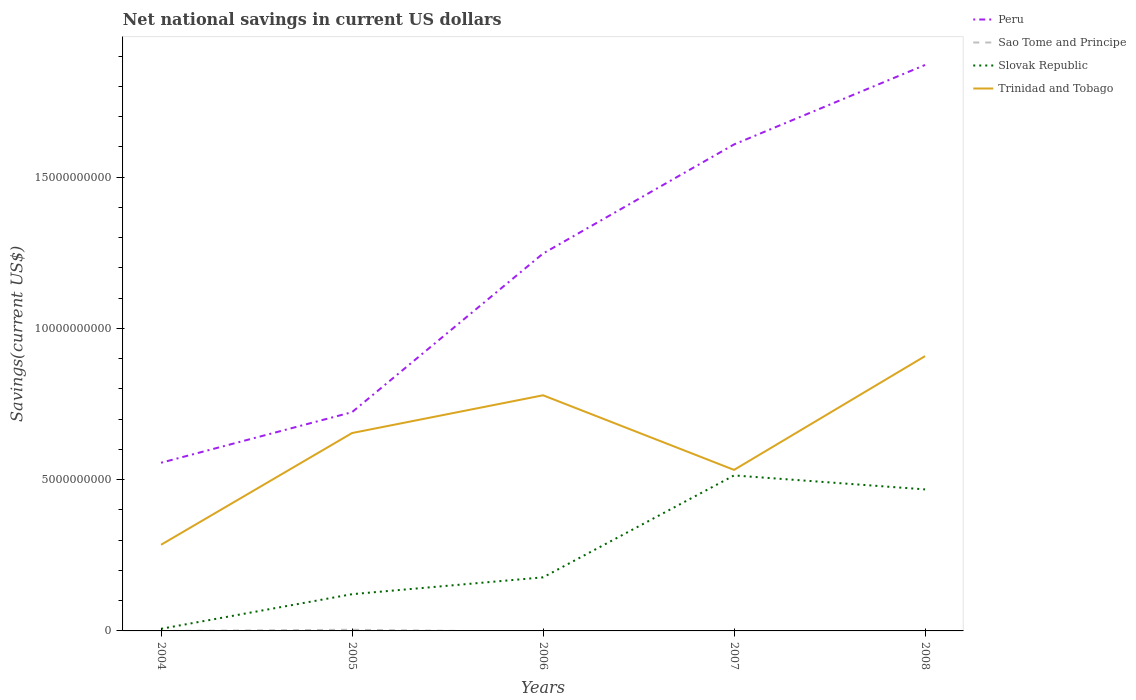How many different coloured lines are there?
Provide a short and direct response. 4. Is the number of lines equal to the number of legend labels?
Offer a terse response. No. Across all years, what is the maximum net national savings in Trinidad and Tobago?
Your answer should be compact. 2.85e+09. What is the total net national savings in Peru in the graph?
Provide a succinct answer. -5.24e+09. What is the difference between the highest and the second highest net national savings in Sao Tome and Principe?
Your response must be concise. 3.84e+07. What is the difference between the highest and the lowest net national savings in Sao Tome and Principe?
Offer a very short reply. 1. Is the net national savings in Trinidad and Tobago strictly greater than the net national savings in Slovak Republic over the years?
Give a very brief answer. No. Does the graph contain grids?
Make the answer very short. No. Where does the legend appear in the graph?
Provide a short and direct response. Top right. How are the legend labels stacked?
Make the answer very short. Vertical. What is the title of the graph?
Offer a very short reply. Net national savings in current US dollars. Does "Jordan" appear as one of the legend labels in the graph?
Your response must be concise. No. What is the label or title of the X-axis?
Your answer should be very brief. Years. What is the label or title of the Y-axis?
Provide a succinct answer. Savings(current US$). What is the Savings(current US$) in Peru in 2004?
Offer a very short reply. 5.56e+09. What is the Savings(current US$) in Slovak Republic in 2004?
Provide a short and direct response. 6.97e+07. What is the Savings(current US$) of Trinidad and Tobago in 2004?
Provide a succinct answer. 2.85e+09. What is the Savings(current US$) of Peru in 2005?
Your response must be concise. 7.23e+09. What is the Savings(current US$) of Sao Tome and Principe in 2005?
Keep it short and to the point. 3.84e+07. What is the Savings(current US$) of Slovak Republic in 2005?
Give a very brief answer. 1.21e+09. What is the Savings(current US$) of Trinidad and Tobago in 2005?
Your answer should be compact. 6.54e+09. What is the Savings(current US$) in Peru in 2006?
Your response must be concise. 1.25e+1. What is the Savings(current US$) of Slovak Republic in 2006?
Ensure brevity in your answer.  1.77e+09. What is the Savings(current US$) in Trinidad and Tobago in 2006?
Provide a succinct answer. 7.79e+09. What is the Savings(current US$) of Peru in 2007?
Give a very brief answer. 1.61e+1. What is the Savings(current US$) of Slovak Republic in 2007?
Your answer should be very brief. 5.14e+09. What is the Savings(current US$) of Trinidad and Tobago in 2007?
Make the answer very short. 5.32e+09. What is the Savings(current US$) in Peru in 2008?
Keep it short and to the point. 1.87e+1. What is the Savings(current US$) of Slovak Republic in 2008?
Make the answer very short. 4.68e+09. What is the Savings(current US$) of Trinidad and Tobago in 2008?
Provide a short and direct response. 9.08e+09. Across all years, what is the maximum Savings(current US$) in Peru?
Ensure brevity in your answer.  1.87e+1. Across all years, what is the maximum Savings(current US$) in Sao Tome and Principe?
Your response must be concise. 3.84e+07. Across all years, what is the maximum Savings(current US$) in Slovak Republic?
Give a very brief answer. 5.14e+09. Across all years, what is the maximum Savings(current US$) of Trinidad and Tobago?
Offer a very short reply. 9.08e+09. Across all years, what is the minimum Savings(current US$) in Peru?
Your answer should be very brief. 5.56e+09. Across all years, what is the minimum Savings(current US$) of Slovak Republic?
Provide a succinct answer. 6.97e+07. Across all years, what is the minimum Savings(current US$) in Trinidad and Tobago?
Offer a very short reply. 2.85e+09. What is the total Savings(current US$) in Peru in the graph?
Your answer should be very brief. 6.01e+1. What is the total Savings(current US$) of Sao Tome and Principe in the graph?
Your answer should be compact. 3.84e+07. What is the total Savings(current US$) in Slovak Republic in the graph?
Your answer should be very brief. 1.29e+1. What is the total Savings(current US$) of Trinidad and Tobago in the graph?
Make the answer very short. 3.16e+1. What is the difference between the Savings(current US$) in Peru in 2004 and that in 2005?
Your response must be concise. -1.67e+09. What is the difference between the Savings(current US$) in Slovak Republic in 2004 and that in 2005?
Provide a succinct answer. -1.14e+09. What is the difference between the Savings(current US$) in Trinidad and Tobago in 2004 and that in 2005?
Ensure brevity in your answer.  -3.69e+09. What is the difference between the Savings(current US$) in Peru in 2004 and that in 2006?
Keep it short and to the point. -6.92e+09. What is the difference between the Savings(current US$) of Slovak Republic in 2004 and that in 2006?
Your answer should be compact. -1.70e+09. What is the difference between the Savings(current US$) in Trinidad and Tobago in 2004 and that in 2006?
Your answer should be compact. -4.94e+09. What is the difference between the Savings(current US$) in Peru in 2004 and that in 2007?
Give a very brief answer. -1.05e+1. What is the difference between the Savings(current US$) in Slovak Republic in 2004 and that in 2007?
Offer a terse response. -5.07e+09. What is the difference between the Savings(current US$) in Trinidad and Tobago in 2004 and that in 2007?
Offer a very short reply. -2.48e+09. What is the difference between the Savings(current US$) of Peru in 2004 and that in 2008?
Provide a short and direct response. -1.31e+1. What is the difference between the Savings(current US$) in Slovak Republic in 2004 and that in 2008?
Keep it short and to the point. -4.61e+09. What is the difference between the Savings(current US$) in Trinidad and Tobago in 2004 and that in 2008?
Provide a succinct answer. -6.23e+09. What is the difference between the Savings(current US$) of Peru in 2005 and that in 2006?
Offer a very short reply. -5.24e+09. What is the difference between the Savings(current US$) in Slovak Republic in 2005 and that in 2006?
Provide a succinct answer. -5.56e+08. What is the difference between the Savings(current US$) of Trinidad and Tobago in 2005 and that in 2006?
Provide a succinct answer. -1.25e+09. What is the difference between the Savings(current US$) in Peru in 2005 and that in 2007?
Offer a terse response. -8.85e+09. What is the difference between the Savings(current US$) of Slovak Republic in 2005 and that in 2007?
Your answer should be very brief. -3.92e+09. What is the difference between the Savings(current US$) in Trinidad and Tobago in 2005 and that in 2007?
Your answer should be very brief. 1.22e+09. What is the difference between the Savings(current US$) in Peru in 2005 and that in 2008?
Provide a short and direct response. -1.15e+1. What is the difference between the Savings(current US$) in Slovak Republic in 2005 and that in 2008?
Provide a short and direct response. -3.46e+09. What is the difference between the Savings(current US$) of Trinidad and Tobago in 2005 and that in 2008?
Your answer should be very brief. -2.54e+09. What is the difference between the Savings(current US$) of Peru in 2006 and that in 2007?
Your response must be concise. -3.61e+09. What is the difference between the Savings(current US$) of Slovak Republic in 2006 and that in 2007?
Your response must be concise. -3.37e+09. What is the difference between the Savings(current US$) of Trinidad and Tobago in 2006 and that in 2007?
Offer a very short reply. 2.47e+09. What is the difference between the Savings(current US$) of Peru in 2006 and that in 2008?
Offer a terse response. -6.23e+09. What is the difference between the Savings(current US$) in Slovak Republic in 2006 and that in 2008?
Keep it short and to the point. -2.91e+09. What is the difference between the Savings(current US$) in Trinidad and Tobago in 2006 and that in 2008?
Keep it short and to the point. -1.29e+09. What is the difference between the Savings(current US$) in Peru in 2007 and that in 2008?
Offer a very short reply. -2.63e+09. What is the difference between the Savings(current US$) in Slovak Republic in 2007 and that in 2008?
Your answer should be compact. 4.62e+08. What is the difference between the Savings(current US$) of Trinidad and Tobago in 2007 and that in 2008?
Offer a terse response. -3.76e+09. What is the difference between the Savings(current US$) in Peru in 2004 and the Savings(current US$) in Sao Tome and Principe in 2005?
Offer a very short reply. 5.52e+09. What is the difference between the Savings(current US$) of Peru in 2004 and the Savings(current US$) of Slovak Republic in 2005?
Your response must be concise. 4.34e+09. What is the difference between the Savings(current US$) of Peru in 2004 and the Savings(current US$) of Trinidad and Tobago in 2005?
Your answer should be very brief. -9.82e+08. What is the difference between the Savings(current US$) in Slovak Republic in 2004 and the Savings(current US$) in Trinidad and Tobago in 2005?
Offer a terse response. -6.47e+09. What is the difference between the Savings(current US$) in Peru in 2004 and the Savings(current US$) in Slovak Republic in 2006?
Keep it short and to the point. 3.79e+09. What is the difference between the Savings(current US$) in Peru in 2004 and the Savings(current US$) in Trinidad and Tobago in 2006?
Offer a terse response. -2.23e+09. What is the difference between the Savings(current US$) in Slovak Republic in 2004 and the Savings(current US$) in Trinidad and Tobago in 2006?
Provide a short and direct response. -7.72e+09. What is the difference between the Savings(current US$) of Peru in 2004 and the Savings(current US$) of Slovak Republic in 2007?
Your answer should be compact. 4.19e+08. What is the difference between the Savings(current US$) of Peru in 2004 and the Savings(current US$) of Trinidad and Tobago in 2007?
Your response must be concise. 2.36e+08. What is the difference between the Savings(current US$) in Slovak Republic in 2004 and the Savings(current US$) in Trinidad and Tobago in 2007?
Give a very brief answer. -5.25e+09. What is the difference between the Savings(current US$) of Peru in 2004 and the Savings(current US$) of Slovak Republic in 2008?
Keep it short and to the point. 8.81e+08. What is the difference between the Savings(current US$) of Peru in 2004 and the Savings(current US$) of Trinidad and Tobago in 2008?
Your response must be concise. -3.52e+09. What is the difference between the Savings(current US$) in Slovak Republic in 2004 and the Savings(current US$) in Trinidad and Tobago in 2008?
Ensure brevity in your answer.  -9.01e+09. What is the difference between the Savings(current US$) in Peru in 2005 and the Savings(current US$) in Slovak Republic in 2006?
Your answer should be very brief. 5.46e+09. What is the difference between the Savings(current US$) of Peru in 2005 and the Savings(current US$) of Trinidad and Tobago in 2006?
Your answer should be very brief. -5.58e+08. What is the difference between the Savings(current US$) of Sao Tome and Principe in 2005 and the Savings(current US$) of Slovak Republic in 2006?
Ensure brevity in your answer.  -1.73e+09. What is the difference between the Savings(current US$) of Sao Tome and Principe in 2005 and the Savings(current US$) of Trinidad and Tobago in 2006?
Give a very brief answer. -7.75e+09. What is the difference between the Savings(current US$) of Slovak Republic in 2005 and the Savings(current US$) of Trinidad and Tobago in 2006?
Make the answer very short. -6.57e+09. What is the difference between the Savings(current US$) in Peru in 2005 and the Savings(current US$) in Slovak Republic in 2007?
Provide a succinct answer. 2.09e+09. What is the difference between the Savings(current US$) in Peru in 2005 and the Savings(current US$) in Trinidad and Tobago in 2007?
Offer a terse response. 1.91e+09. What is the difference between the Savings(current US$) of Sao Tome and Principe in 2005 and the Savings(current US$) of Slovak Republic in 2007?
Your response must be concise. -5.10e+09. What is the difference between the Savings(current US$) in Sao Tome and Principe in 2005 and the Savings(current US$) in Trinidad and Tobago in 2007?
Your answer should be compact. -5.28e+09. What is the difference between the Savings(current US$) in Slovak Republic in 2005 and the Savings(current US$) in Trinidad and Tobago in 2007?
Your response must be concise. -4.11e+09. What is the difference between the Savings(current US$) in Peru in 2005 and the Savings(current US$) in Slovak Republic in 2008?
Ensure brevity in your answer.  2.55e+09. What is the difference between the Savings(current US$) of Peru in 2005 and the Savings(current US$) of Trinidad and Tobago in 2008?
Your answer should be very brief. -1.85e+09. What is the difference between the Savings(current US$) in Sao Tome and Principe in 2005 and the Savings(current US$) in Slovak Republic in 2008?
Keep it short and to the point. -4.64e+09. What is the difference between the Savings(current US$) of Sao Tome and Principe in 2005 and the Savings(current US$) of Trinidad and Tobago in 2008?
Ensure brevity in your answer.  -9.04e+09. What is the difference between the Savings(current US$) in Slovak Republic in 2005 and the Savings(current US$) in Trinidad and Tobago in 2008?
Your answer should be very brief. -7.87e+09. What is the difference between the Savings(current US$) in Peru in 2006 and the Savings(current US$) in Slovak Republic in 2007?
Provide a succinct answer. 7.33e+09. What is the difference between the Savings(current US$) in Peru in 2006 and the Savings(current US$) in Trinidad and Tobago in 2007?
Keep it short and to the point. 7.15e+09. What is the difference between the Savings(current US$) of Slovak Republic in 2006 and the Savings(current US$) of Trinidad and Tobago in 2007?
Your answer should be very brief. -3.55e+09. What is the difference between the Savings(current US$) of Peru in 2006 and the Savings(current US$) of Slovak Republic in 2008?
Offer a very short reply. 7.80e+09. What is the difference between the Savings(current US$) of Peru in 2006 and the Savings(current US$) of Trinidad and Tobago in 2008?
Provide a short and direct response. 3.39e+09. What is the difference between the Savings(current US$) in Slovak Republic in 2006 and the Savings(current US$) in Trinidad and Tobago in 2008?
Keep it short and to the point. -7.31e+09. What is the difference between the Savings(current US$) in Peru in 2007 and the Savings(current US$) in Slovak Republic in 2008?
Give a very brief answer. 1.14e+1. What is the difference between the Savings(current US$) of Peru in 2007 and the Savings(current US$) of Trinidad and Tobago in 2008?
Offer a very short reply. 7.00e+09. What is the difference between the Savings(current US$) in Slovak Republic in 2007 and the Savings(current US$) in Trinidad and Tobago in 2008?
Offer a terse response. -3.94e+09. What is the average Savings(current US$) in Peru per year?
Your answer should be compact. 1.20e+1. What is the average Savings(current US$) in Sao Tome and Principe per year?
Provide a short and direct response. 7.68e+06. What is the average Savings(current US$) in Slovak Republic per year?
Your answer should be very brief. 2.57e+09. What is the average Savings(current US$) of Trinidad and Tobago per year?
Keep it short and to the point. 6.32e+09. In the year 2004, what is the difference between the Savings(current US$) in Peru and Savings(current US$) in Slovak Republic?
Your answer should be very brief. 5.49e+09. In the year 2004, what is the difference between the Savings(current US$) of Peru and Savings(current US$) of Trinidad and Tobago?
Provide a short and direct response. 2.71e+09. In the year 2004, what is the difference between the Savings(current US$) in Slovak Republic and Savings(current US$) in Trinidad and Tobago?
Offer a very short reply. -2.78e+09. In the year 2005, what is the difference between the Savings(current US$) in Peru and Savings(current US$) in Sao Tome and Principe?
Your answer should be compact. 7.19e+09. In the year 2005, what is the difference between the Savings(current US$) of Peru and Savings(current US$) of Slovak Republic?
Make the answer very short. 6.02e+09. In the year 2005, what is the difference between the Savings(current US$) in Peru and Savings(current US$) in Trinidad and Tobago?
Ensure brevity in your answer.  6.90e+08. In the year 2005, what is the difference between the Savings(current US$) of Sao Tome and Principe and Savings(current US$) of Slovak Republic?
Provide a succinct answer. -1.18e+09. In the year 2005, what is the difference between the Savings(current US$) in Sao Tome and Principe and Savings(current US$) in Trinidad and Tobago?
Ensure brevity in your answer.  -6.50e+09. In the year 2005, what is the difference between the Savings(current US$) of Slovak Republic and Savings(current US$) of Trinidad and Tobago?
Offer a terse response. -5.33e+09. In the year 2006, what is the difference between the Savings(current US$) of Peru and Savings(current US$) of Slovak Republic?
Provide a succinct answer. 1.07e+1. In the year 2006, what is the difference between the Savings(current US$) of Peru and Savings(current US$) of Trinidad and Tobago?
Offer a very short reply. 4.69e+09. In the year 2006, what is the difference between the Savings(current US$) of Slovak Republic and Savings(current US$) of Trinidad and Tobago?
Keep it short and to the point. -6.02e+09. In the year 2007, what is the difference between the Savings(current US$) of Peru and Savings(current US$) of Slovak Republic?
Your answer should be very brief. 1.09e+1. In the year 2007, what is the difference between the Savings(current US$) of Peru and Savings(current US$) of Trinidad and Tobago?
Provide a short and direct response. 1.08e+1. In the year 2007, what is the difference between the Savings(current US$) in Slovak Republic and Savings(current US$) in Trinidad and Tobago?
Provide a succinct answer. -1.83e+08. In the year 2008, what is the difference between the Savings(current US$) in Peru and Savings(current US$) in Slovak Republic?
Give a very brief answer. 1.40e+1. In the year 2008, what is the difference between the Savings(current US$) of Peru and Savings(current US$) of Trinidad and Tobago?
Make the answer very short. 9.62e+09. In the year 2008, what is the difference between the Savings(current US$) in Slovak Republic and Savings(current US$) in Trinidad and Tobago?
Provide a succinct answer. -4.41e+09. What is the ratio of the Savings(current US$) of Peru in 2004 to that in 2005?
Your response must be concise. 0.77. What is the ratio of the Savings(current US$) of Slovak Republic in 2004 to that in 2005?
Give a very brief answer. 0.06. What is the ratio of the Savings(current US$) in Trinidad and Tobago in 2004 to that in 2005?
Your response must be concise. 0.44. What is the ratio of the Savings(current US$) in Peru in 2004 to that in 2006?
Provide a succinct answer. 0.45. What is the ratio of the Savings(current US$) of Slovak Republic in 2004 to that in 2006?
Give a very brief answer. 0.04. What is the ratio of the Savings(current US$) of Trinidad and Tobago in 2004 to that in 2006?
Provide a succinct answer. 0.37. What is the ratio of the Savings(current US$) of Peru in 2004 to that in 2007?
Provide a short and direct response. 0.35. What is the ratio of the Savings(current US$) of Slovak Republic in 2004 to that in 2007?
Offer a very short reply. 0.01. What is the ratio of the Savings(current US$) in Trinidad and Tobago in 2004 to that in 2007?
Offer a terse response. 0.54. What is the ratio of the Savings(current US$) in Peru in 2004 to that in 2008?
Offer a terse response. 0.3. What is the ratio of the Savings(current US$) in Slovak Republic in 2004 to that in 2008?
Make the answer very short. 0.01. What is the ratio of the Savings(current US$) in Trinidad and Tobago in 2004 to that in 2008?
Your response must be concise. 0.31. What is the ratio of the Savings(current US$) of Peru in 2005 to that in 2006?
Your answer should be very brief. 0.58. What is the ratio of the Savings(current US$) in Slovak Republic in 2005 to that in 2006?
Offer a terse response. 0.69. What is the ratio of the Savings(current US$) of Trinidad and Tobago in 2005 to that in 2006?
Your answer should be very brief. 0.84. What is the ratio of the Savings(current US$) in Peru in 2005 to that in 2007?
Give a very brief answer. 0.45. What is the ratio of the Savings(current US$) in Slovak Republic in 2005 to that in 2007?
Keep it short and to the point. 0.24. What is the ratio of the Savings(current US$) in Trinidad and Tobago in 2005 to that in 2007?
Ensure brevity in your answer.  1.23. What is the ratio of the Savings(current US$) in Peru in 2005 to that in 2008?
Ensure brevity in your answer.  0.39. What is the ratio of the Savings(current US$) of Slovak Republic in 2005 to that in 2008?
Keep it short and to the point. 0.26. What is the ratio of the Savings(current US$) of Trinidad and Tobago in 2005 to that in 2008?
Give a very brief answer. 0.72. What is the ratio of the Savings(current US$) of Peru in 2006 to that in 2007?
Give a very brief answer. 0.78. What is the ratio of the Savings(current US$) of Slovak Republic in 2006 to that in 2007?
Your answer should be compact. 0.34. What is the ratio of the Savings(current US$) of Trinidad and Tobago in 2006 to that in 2007?
Offer a terse response. 1.46. What is the ratio of the Savings(current US$) in Peru in 2006 to that in 2008?
Keep it short and to the point. 0.67. What is the ratio of the Savings(current US$) of Slovak Republic in 2006 to that in 2008?
Provide a succinct answer. 0.38. What is the ratio of the Savings(current US$) of Trinidad and Tobago in 2006 to that in 2008?
Your answer should be very brief. 0.86. What is the ratio of the Savings(current US$) in Peru in 2007 to that in 2008?
Offer a terse response. 0.86. What is the ratio of the Savings(current US$) in Slovak Republic in 2007 to that in 2008?
Your response must be concise. 1.1. What is the ratio of the Savings(current US$) in Trinidad and Tobago in 2007 to that in 2008?
Your answer should be compact. 0.59. What is the difference between the highest and the second highest Savings(current US$) of Peru?
Keep it short and to the point. 2.63e+09. What is the difference between the highest and the second highest Savings(current US$) in Slovak Republic?
Your answer should be compact. 4.62e+08. What is the difference between the highest and the second highest Savings(current US$) in Trinidad and Tobago?
Ensure brevity in your answer.  1.29e+09. What is the difference between the highest and the lowest Savings(current US$) in Peru?
Ensure brevity in your answer.  1.31e+1. What is the difference between the highest and the lowest Savings(current US$) in Sao Tome and Principe?
Give a very brief answer. 3.84e+07. What is the difference between the highest and the lowest Savings(current US$) in Slovak Republic?
Your answer should be very brief. 5.07e+09. What is the difference between the highest and the lowest Savings(current US$) in Trinidad and Tobago?
Ensure brevity in your answer.  6.23e+09. 